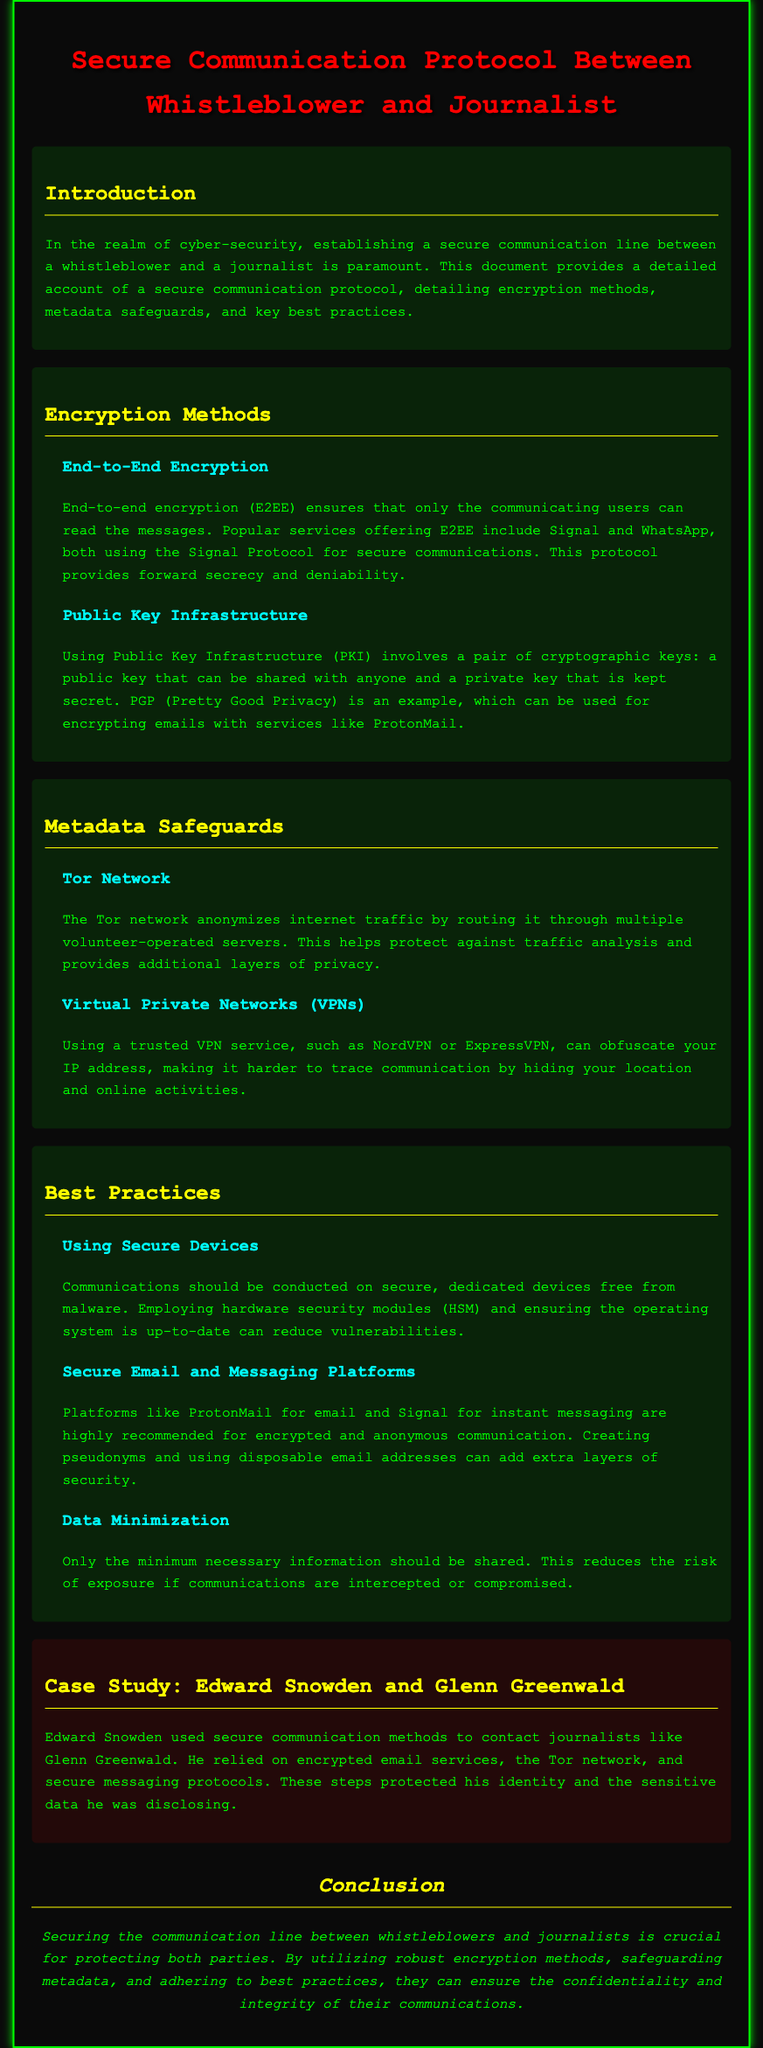what does E2EE stand for? E2EE is an abbreviation used in the document, specifically referring to strong encryption methods discussed in the context of communication security.
Answer: End-to-End Encryption what protocol is used by Signal and WhatsApp? The document names the specific encryption protocol that ensures secure communications for these services.
Answer: Signal Protocol which network anonymizes internet traffic? The document mentions a method that obscures communication by routing traffic through various servers, providing enhanced privacy.
Answer: Tor Network name a recommended secure email service. The document lists a specific email service recognized for its encryption and anonymity features.
Answer: ProtonMail what should be minimized when sharing information? The document emphasizes a crucial practice to maintain security in communications by limiting shared data.
Answer: Data Minimization who was the whistleblower mentioned in the case study? The case study illustrates a real-life example of a whistleblower and journalist interaction, identifying the key individual involved.
Answer: Edward Snowden which VPN services are suggested? The document recommends specific services to mask IP addresses and enhance privacy during communication exchanges.
Answer: NordVPN or ExpressVPN what type of keys does Public Key Infrastructure utilize? The document explains the two distinct keys used in a particular cryptographic method for secure communication.
Answer: Public and Private Keys what is the purpose of using secure devices? The document highlights the importance of this best practice in maintaining a secure communication environment.
Answer: Reduce vulnerabilities 